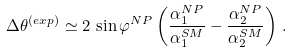<formula> <loc_0><loc_0><loc_500><loc_500>\Delta \theta ^ { ( e x p ) } \simeq 2 \, \sin \varphi ^ { N P } \left ( \frac { \alpha ^ { N P } _ { 1 } } { \alpha ^ { S M } _ { 1 } } - \frac { \alpha ^ { N P } _ { 2 } } { \alpha ^ { S M } _ { 2 } } \right ) \, .</formula> 